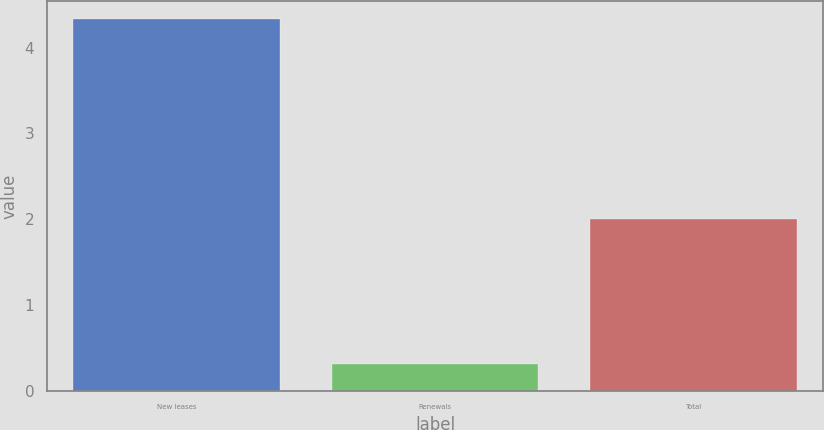<chart> <loc_0><loc_0><loc_500><loc_500><bar_chart><fcel>New leases<fcel>Renewals<fcel>Total<nl><fcel>4.33<fcel>0.32<fcel>2<nl></chart> 